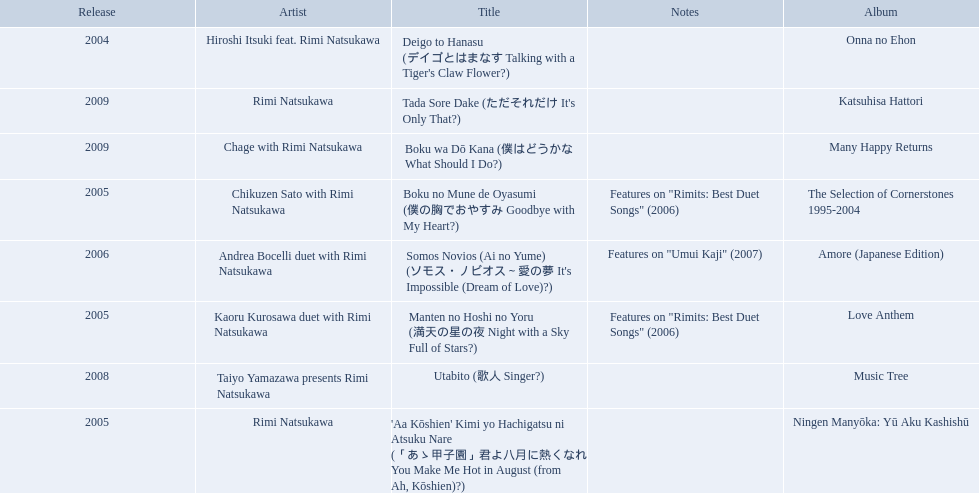What are the notes for sky full of stars? Features on "Rimits: Best Duet Songs" (2006). What other song features this same note? Boku no Mune de Oyasumi (僕の胸でおやすみ Goodbye with My Heart?). 